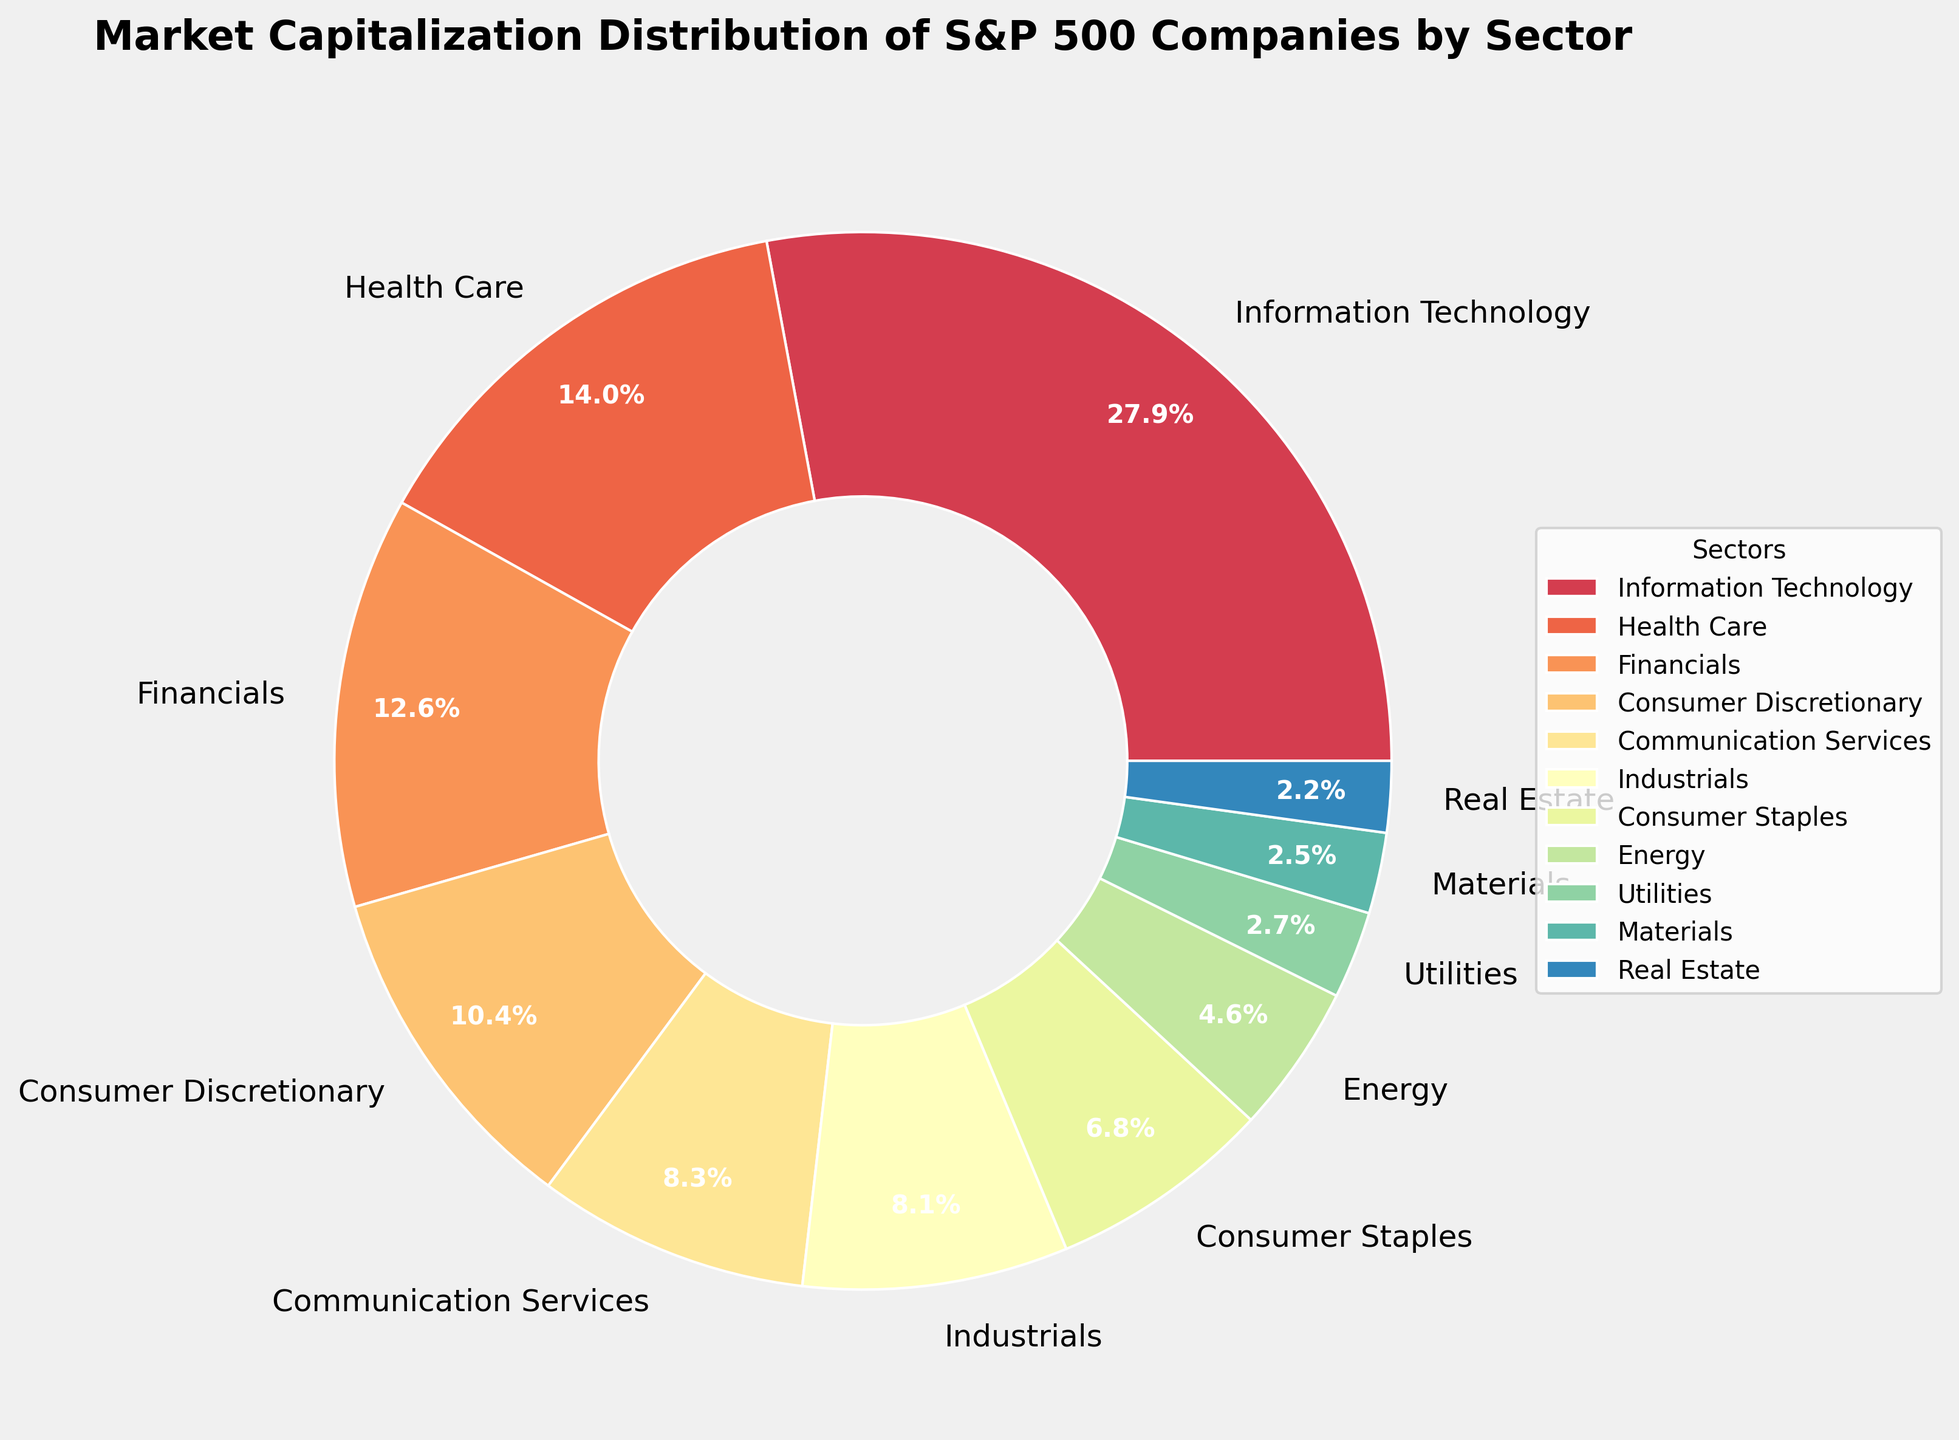Which sector has the largest market capitalization percentage? By looking at the pie chart, identify the sector label with the largest wedge. This wedge should also have the highest percentage.
Answer: Information Technology What is the combined market capitalization percentage of the Health Care and Financials sectors? Look at the pie chart and locate the wedges for Health Care (14.1%) and Financials (12.7%). Add these two percentages together: 14.1 + 12.7 = 26.8.
Answer: 26.8% How does the market capitalization percentage of Energy compare to that of Consumer Staples? From the pie chart, note the percentages for Energy (4.6%) and Consumer Staples (6.9%). Compare the two values and determine that 4.6% is less than 6.9%.
Answer: Energy < Consumer Staples Which sector has the smallest market capitalization percentage, and what is its value? Find the smallest wedge on the pie chart, which is labeled Real Estate, and note its percentage.
Answer: Real Estate, 2.2% What is the difference in market capitalization percentage between Information Technology and Industrials sectors? Identify the percentages for Information Technology (28.2%) and Industrials (8.2%) on the pie chart. Subtract the smaller percentage from the larger one: 28.2 - 8.2 = 20.
Answer: 20 Which three sectors combined make up more than 50% of the market capitalization? From the pie chart, find and sum the top percentages until the total exceeds 50%. Information Technology (28.2%), Health Care (14.1%), and Financials (12.7%) together sum to 28.2 + 14.1 + 12.7 = 55.
Answer: Information Technology, Health Care, Financials What is the average market capitalization percentage of Utilities, Materials, and Real Estate sectors? Find the percentages for Utilities (2.7%), Materials (2.5%), and Real Estate (2.2%) on the pie chart. Calculate the average: (2.7 + 2.5 + 2.2) / 3 = 7.4 / 3 ≈ 2.47.
Answer: 2.47% Which sector represents double the market capitalization percentage of Utilities, and what is the corresponding sector? The Utilities sector has a market capitalization percentage of 2.7%. Double this value is 2.7 * 2 = 5.4%. The sector closest to this value but greater is Consumer Staples (6.9%).
Answer: Consumer Staples, 6.9% What is the sum of the market capitalization percentages for sectors with percentages less than 5%? Identify the sectors with percentages less than 5% in the pie chart: Energy (4.6%), Utilities (2.7%), Materials (2.5%), and Real Estate (2.2%). Add these percentages: 4.6 + 2.7 + 2.5 + 2.2 = 12.
Answer: 12% 